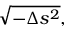<formula> <loc_0><loc_0><loc_500><loc_500>{ \sqrt { - \Delta s ^ { 2 } } } ,</formula> 